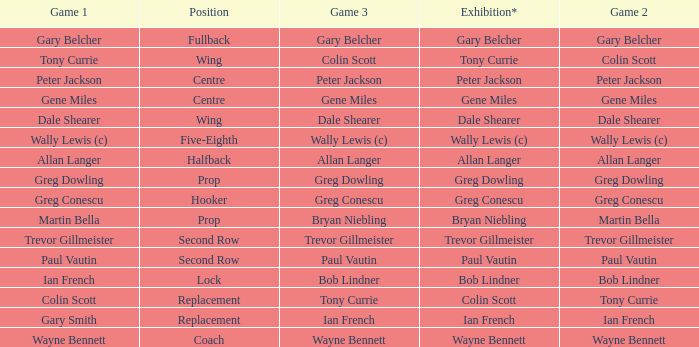What game 1 has bob lindner as game 2? Ian French. 